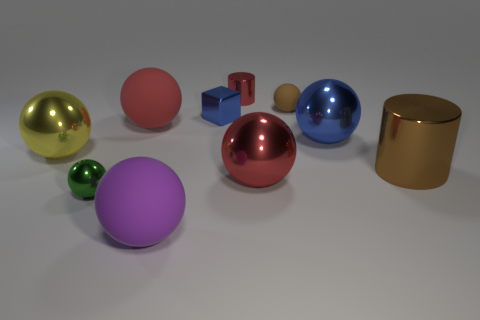Are there any patterns or symmetry in the arrangement of the objects? The arrangement doesn't follow a strict pattern or symmetry. The objects are placed seemingly at random, with various sizes and colors scattered throughout the image, creating a diverse visual field without a clear order or structure. 